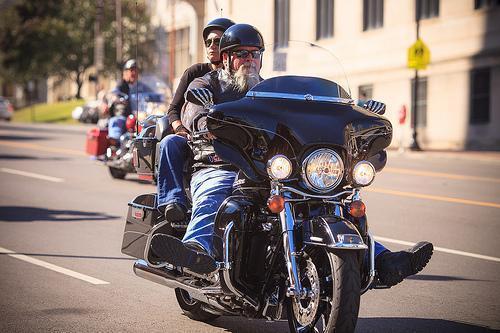How many people are riding one motorcycle?
Give a very brief answer. 2. 